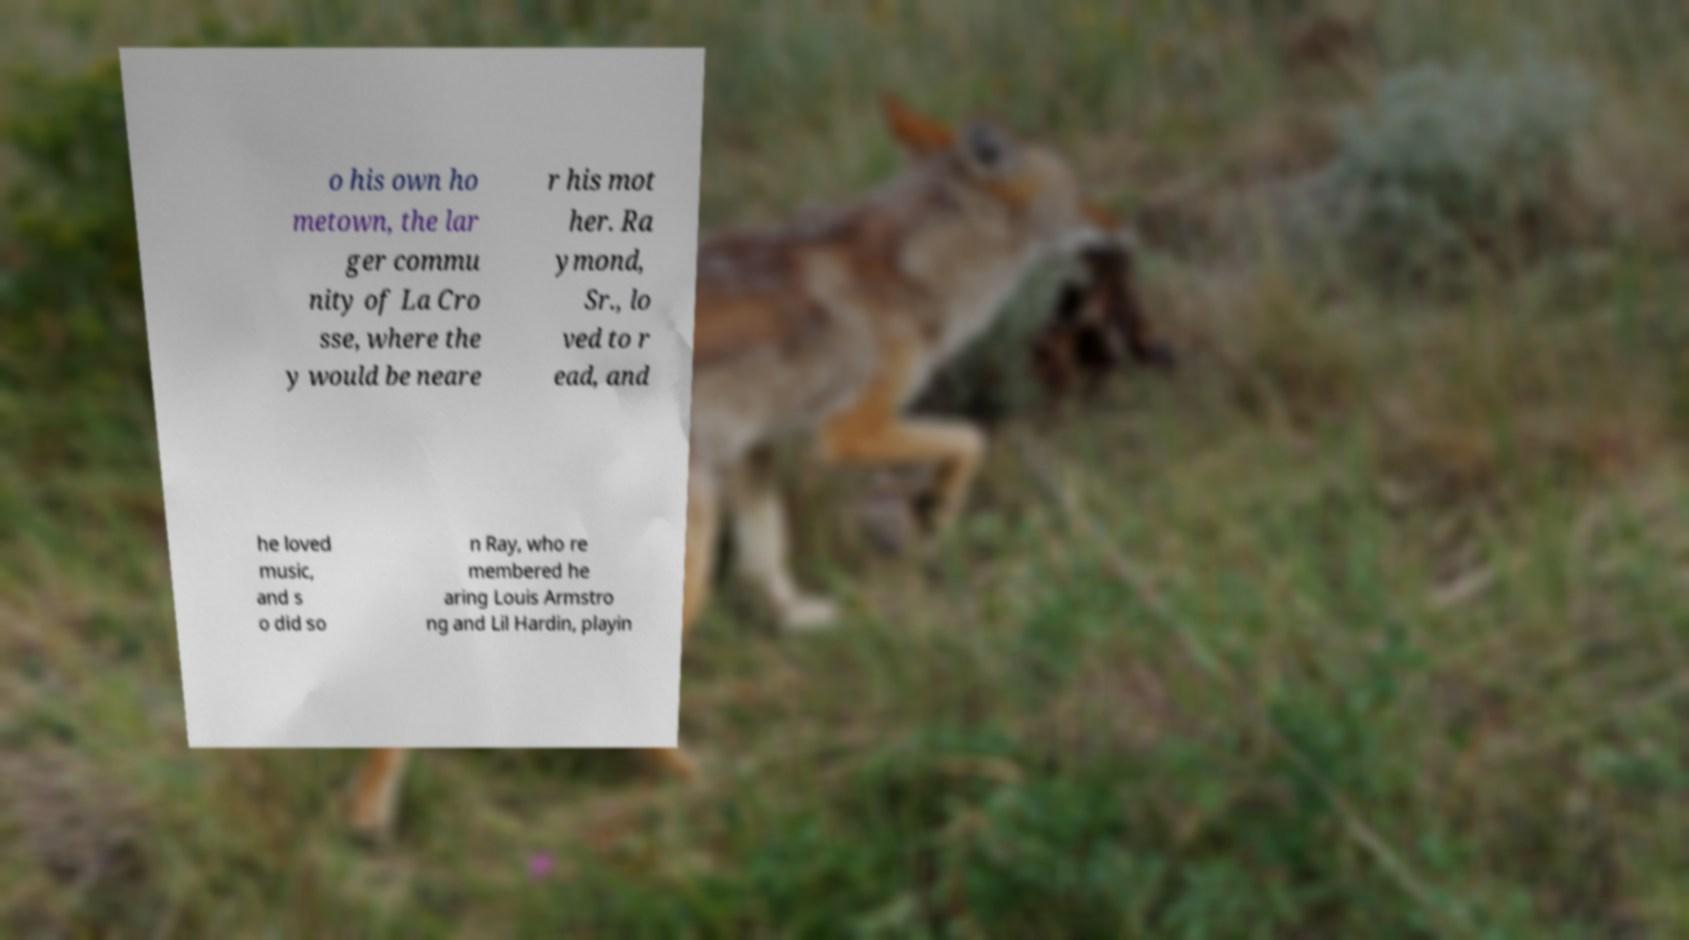Could you extract and type out the text from this image? o his own ho metown, the lar ger commu nity of La Cro sse, where the y would be neare r his mot her. Ra ymond, Sr., lo ved to r ead, and he loved music, and s o did so n Ray, who re membered he aring Louis Armstro ng and Lil Hardin, playin 